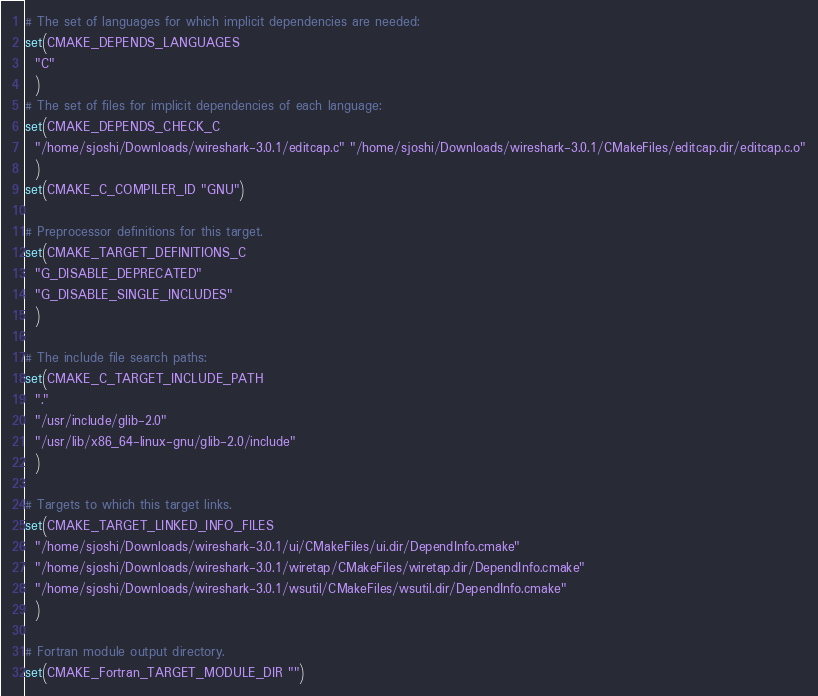Convert code to text. <code><loc_0><loc_0><loc_500><loc_500><_CMake_># The set of languages for which implicit dependencies are needed:
set(CMAKE_DEPENDS_LANGUAGES
  "C"
  )
# The set of files for implicit dependencies of each language:
set(CMAKE_DEPENDS_CHECK_C
  "/home/sjoshi/Downloads/wireshark-3.0.1/editcap.c" "/home/sjoshi/Downloads/wireshark-3.0.1/CMakeFiles/editcap.dir/editcap.c.o"
  )
set(CMAKE_C_COMPILER_ID "GNU")

# Preprocessor definitions for this target.
set(CMAKE_TARGET_DEFINITIONS_C
  "G_DISABLE_DEPRECATED"
  "G_DISABLE_SINGLE_INCLUDES"
  )

# The include file search paths:
set(CMAKE_C_TARGET_INCLUDE_PATH
  "."
  "/usr/include/glib-2.0"
  "/usr/lib/x86_64-linux-gnu/glib-2.0/include"
  )

# Targets to which this target links.
set(CMAKE_TARGET_LINKED_INFO_FILES
  "/home/sjoshi/Downloads/wireshark-3.0.1/ui/CMakeFiles/ui.dir/DependInfo.cmake"
  "/home/sjoshi/Downloads/wireshark-3.0.1/wiretap/CMakeFiles/wiretap.dir/DependInfo.cmake"
  "/home/sjoshi/Downloads/wireshark-3.0.1/wsutil/CMakeFiles/wsutil.dir/DependInfo.cmake"
  )

# Fortran module output directory.
set(CMAKE_Fortran_TARGET_MODULE_DIR "")
</code> 